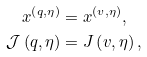<formula> <loc_0><loc_0><loc_500><loc_500>x ^ { \left ( q , \eta \right ) } & = x ^ { \left ( v , \eta \right ) } , \\ \mathcal { J } \left ( q , \eta \right ) & = J \left ( v , \eta \right ) ,</formula> 